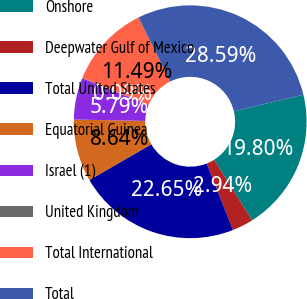<chart> <loc_0><loc_0><loc_500><loc_500><pie_chart><fcel>Onshore<fcel>Deepwater Gulf of Mexico<fcel>Total United States<fcel>Equatorial Guinea<fcel>Israel (1)<fcel>United Kingdom<fcel>Total International<fcel>Total<nl><fcel>19.8%<fcel>2.94%<fcel>22.65%<fcel>8.64%<fcel>5.79%<fcel>0.09%<fcel>11.49%<fcel>28.59%<nl></chart> 